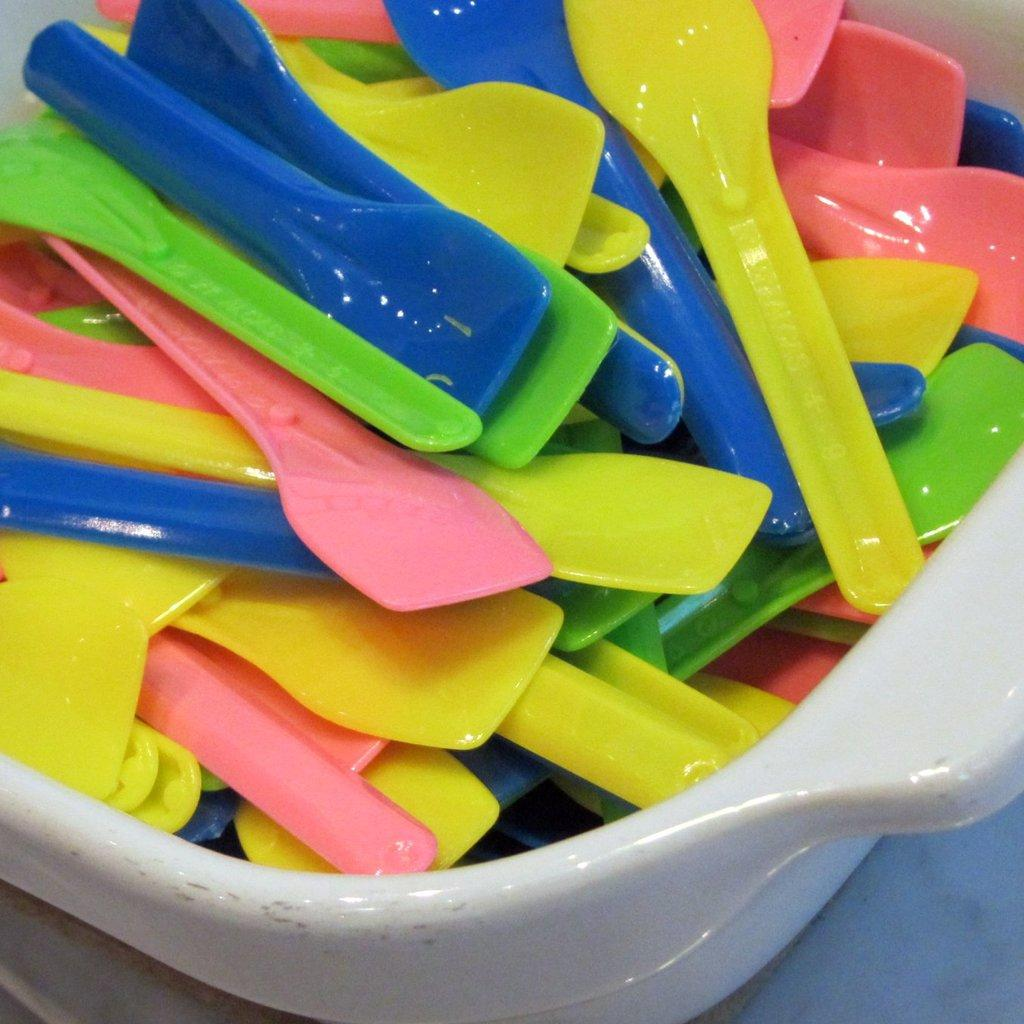What type of utensils are visible in the image? There are plastic spoons visible in the image. How many sisters are visible in the image? There are no sisters present in the image; it only features plastic spoons. What type of plants can be seen growing near the plastic spoons in the image? There are no plants visible in the image; it only features plastic spoons. 